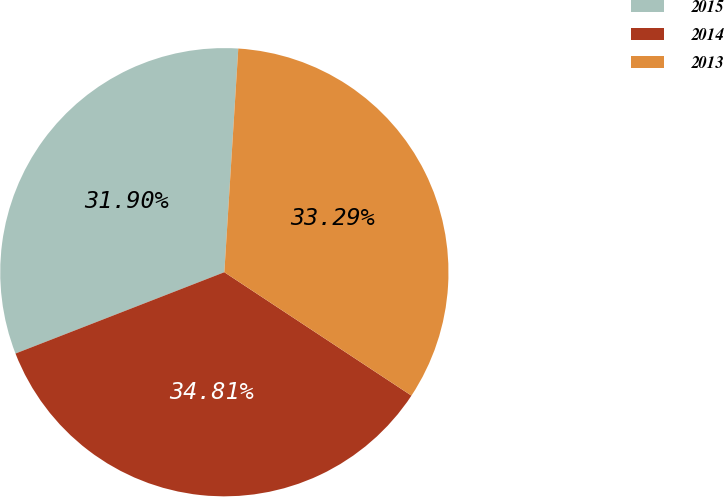Convert chart. <chart><loc_0><loc_0><loc_500><loc_500><pie_chart><fcel>2015<fcel>2014<fcel>2013<nl><fcel>31.9%<fcel>34.81%<fcel>33.29%<nl></chart> 